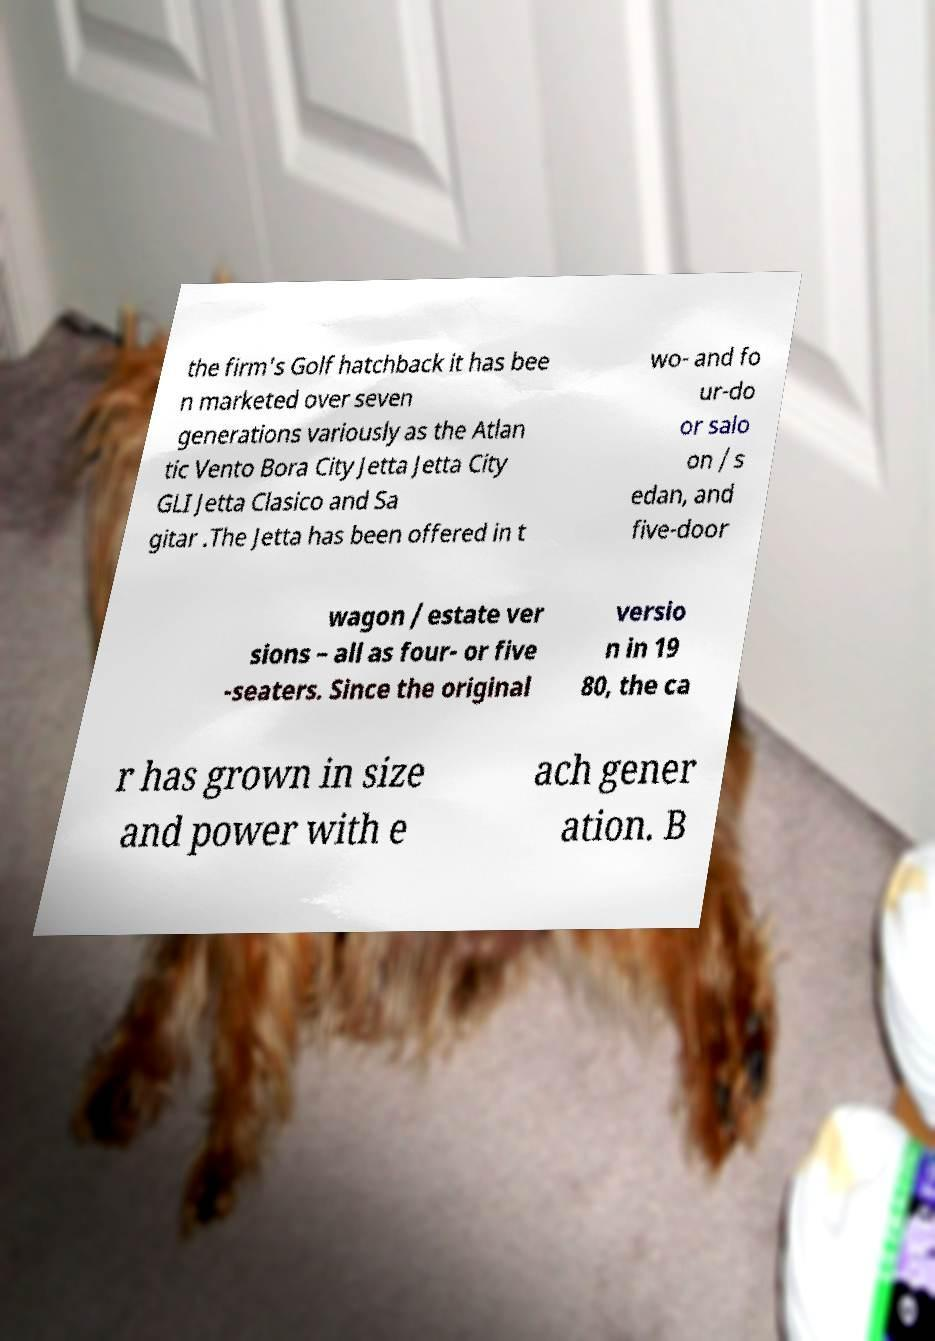What messages or text are displayed in this image? I need them in a readable, typed format. the firm's Golf hatchback it has bee n marketed over seven generations variously as the Atlan tic Vento Bora City Jetta Jetta City GLI Jetta Clasico and Sa gitar .The Jetta has been offered in t wo- and fo ur-do or salo on / s edan, and five-door wagon / estate ver sions – all as four- or five -seaters. Since the original versio n in 19 80, the ca r has grown in size and power with e ach gener ation. B 